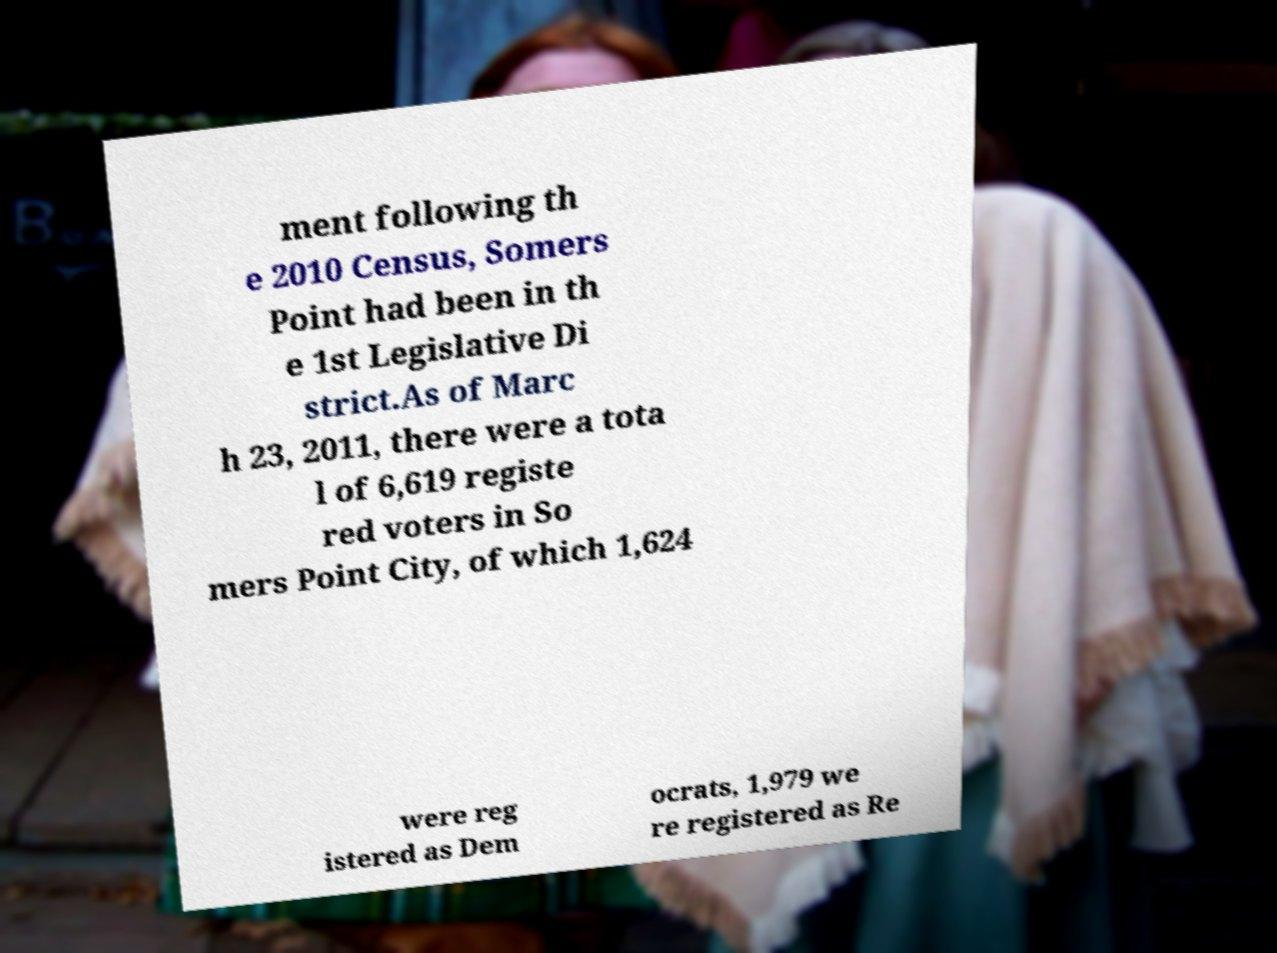Could you extract and type out the text from this image? ment following th e 2010 Census, Somers Point had been in th e 1st Legislative Di strict.As of Marc h 23, 2011, there were a tota l of 6,619 registe red voters in So mers Point City, of which 1,624 were reg istered as Dem ocrats, 1,979 we re registered as Re 